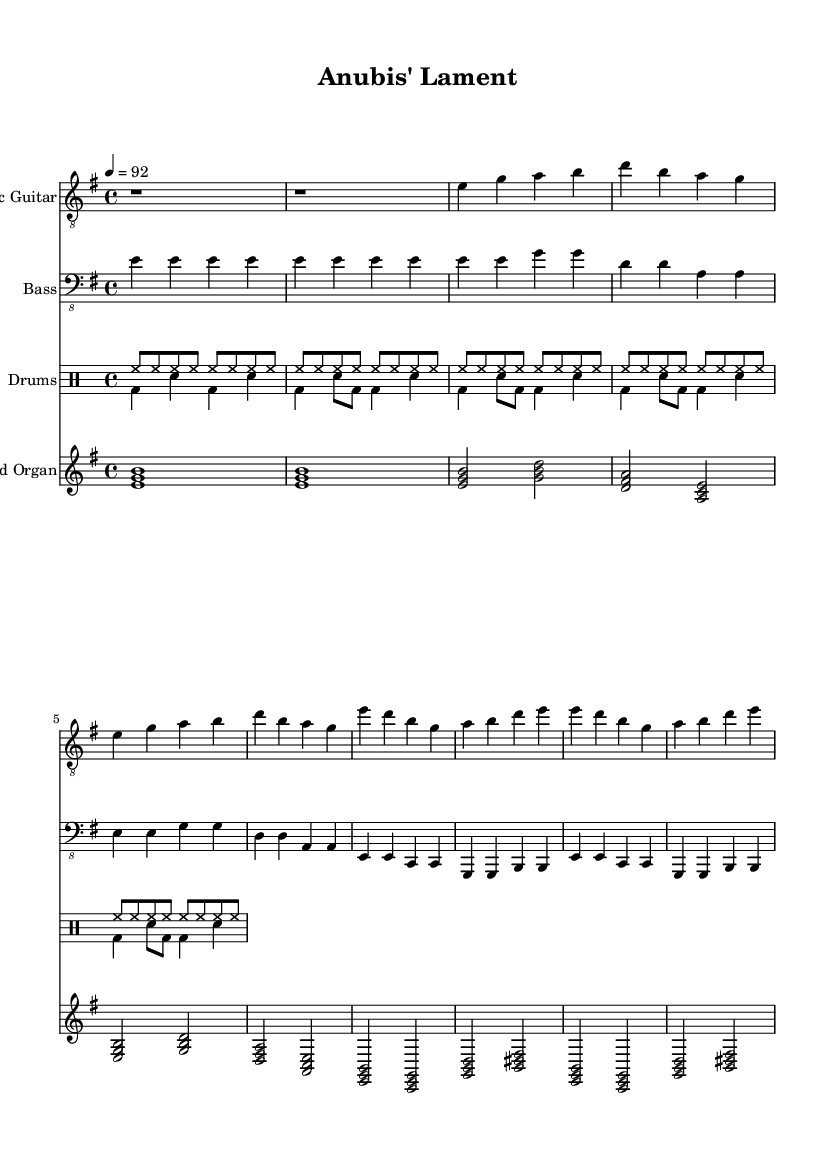What is the key signature of this music? The key signature is E minor, which has one sharp (F#). This can be identified by looking at the key indicated at the beginning of the score, denoted with a sharp sign next to F.
Answer: E minor What is the time signature of this music? The time signature is 4/4, which means there are four beats in each measure and a quarter note receives one beat. This is indicated in the top left corner of the sheet music.
Answer: 4/4 What is the tempo marking of this music? The tempo marking is "4 = 92," meaning that there are 92 quarter-note beats per minute. This is shown at the start of the score next to the time signature.
Answer: 92 How many measures are in the verse section of this piece? The verse section consists of 4 measures, which can be counted by seeing the notation provided under the "Verse 1" label. Each line, separated by a barline, represents a measure.
Answer: 4 What are the instruments used in this piece? The instruments used are Electric Guitar, Bass, Drums, and Hammond Organ. This can be determined from the instrument names listed at the start of each staff in the score.
Answer: Electric Guitar, Bass, Drums, Hammond Organ How does the drum pattern change between the intro and the verse? In the intro, the drum pattern consists only of hi-hat hits, while in the verse, the bass drum and snare are introduced, creating a more complex rhythmic texture. This difference is noted in the "drummode" section, where the respective drum patterns are coded distinctly.
Answer: From hi-hat to bass and snare What is the shortest duration of a note in this piece? The shortest duration of a note in this piece is an eighth note, as evidenced by the use of "sn" (snare) notations in the drumming section, which indicates eighth-note hits.
Answer: Eighth note 